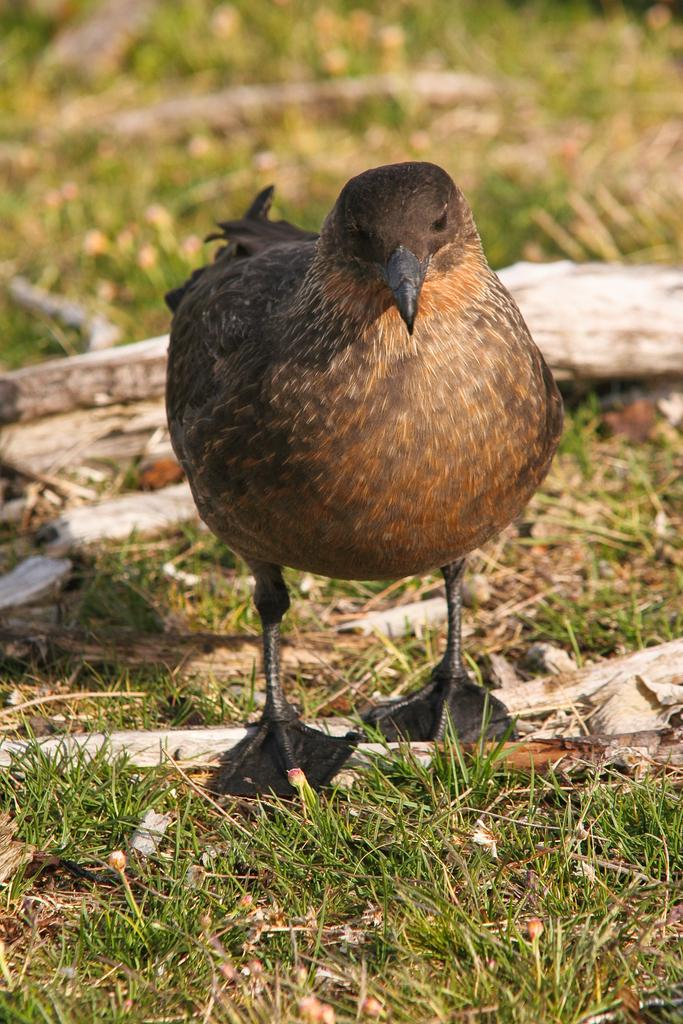What is the main subject in the center of the image? There is a bird in the center of the image. What type of vegetation can be seen in the image? There is green grass visible in the image. What else can be found on the ground in the image? There are other objects lying on the ground in the image. What type of pot is the son using for punishment in the image? There is no pot or son present in the image, and therefore no such activity can be observed. 